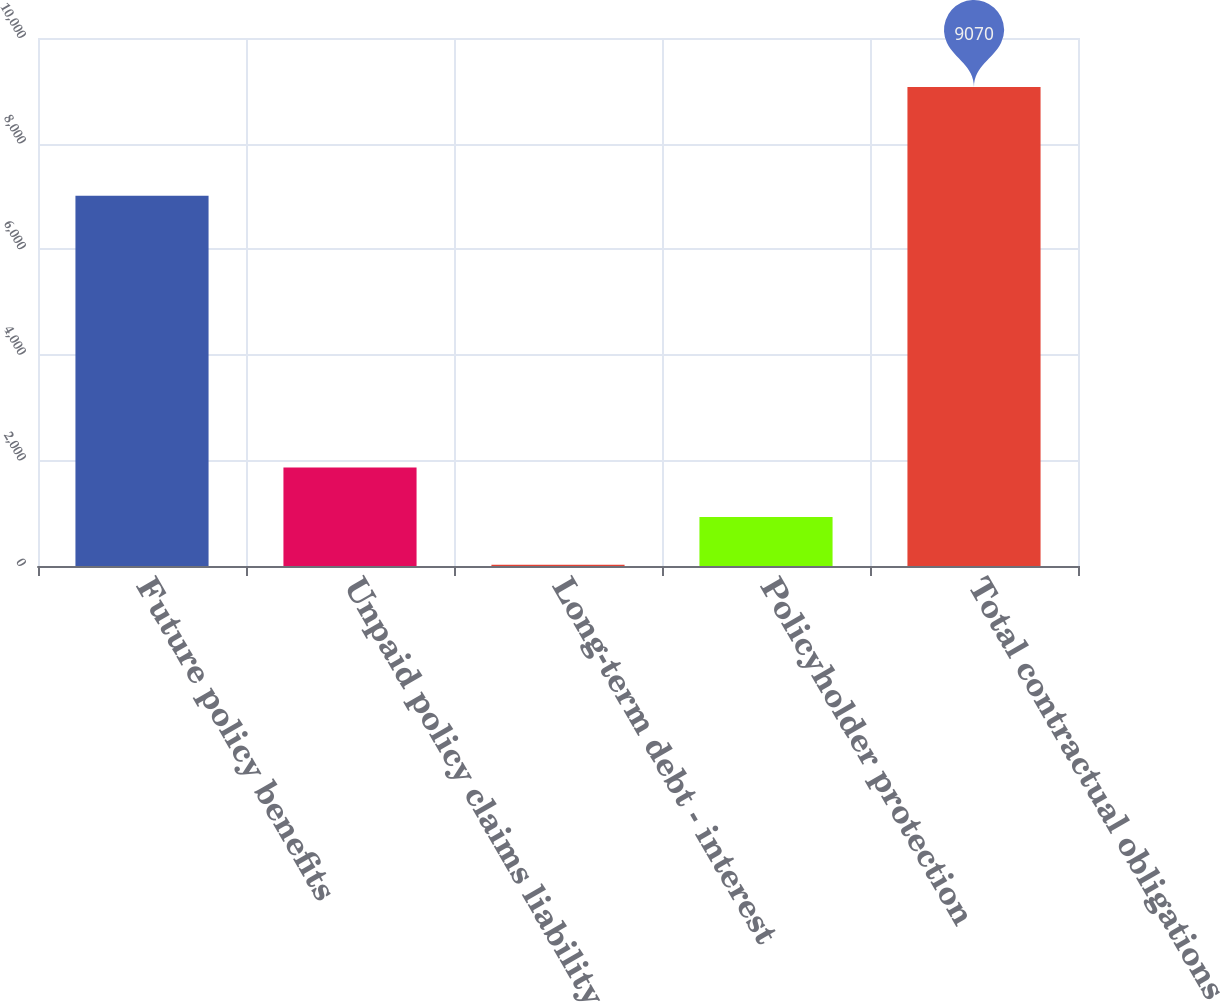Convert chart. <chart><loc_0><loc_0><loc_500><loc_500><bar_chart><fcel>Future policy benefits<fcel>Unpaid policy claims liability<fcel>Long-term debt - interest<fcel>Policyholder protection<fcel>Total contractual obligations<nl><fcel>7014<fcel>1866<fcel>22<fcel>926.8<fcel>9070<nl></chart> 